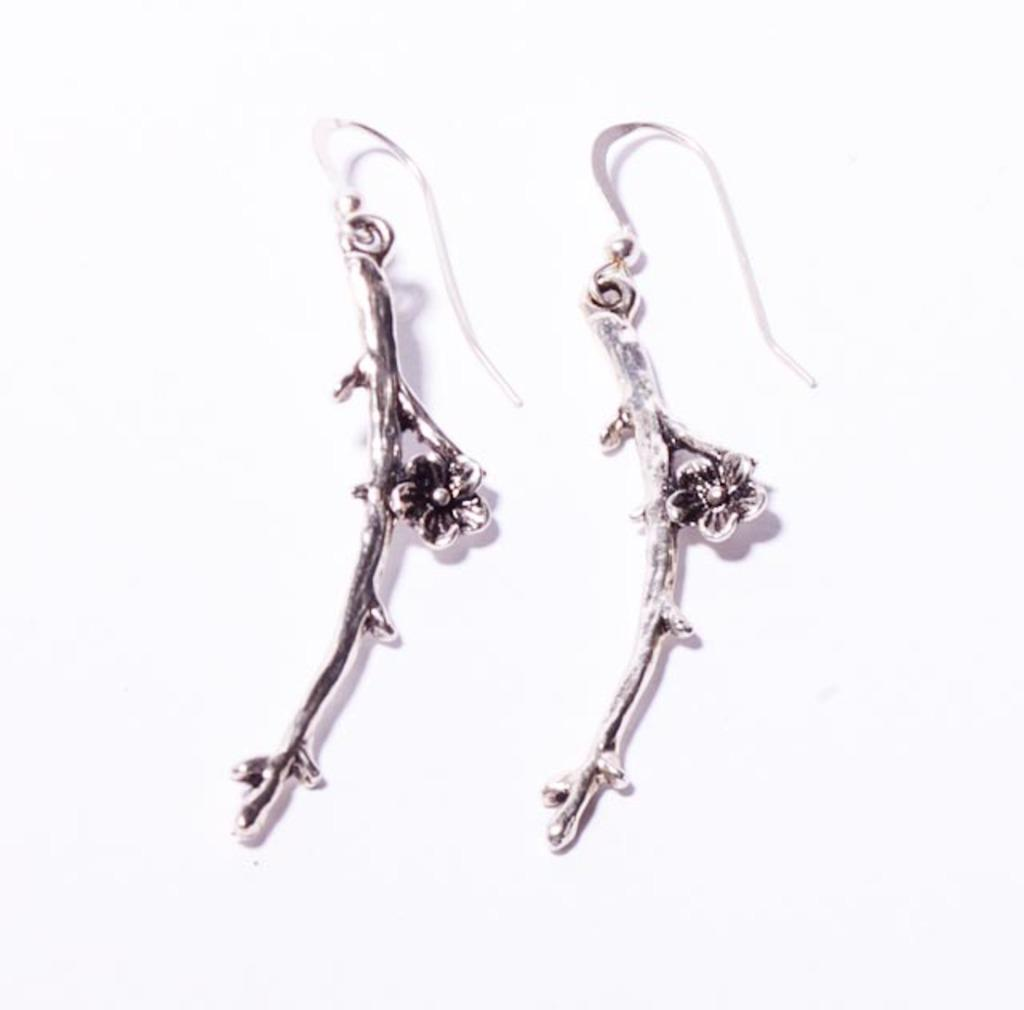What type of accessory is present in the image? There is a pair of earrings in the image. Can you describe the earrings in more detail? Unfortunately, the image does not provide enough detail to describe the earrings further. What type of toe is visible in the image? There is no toe visible in the image; it only features a pair of earrings. 